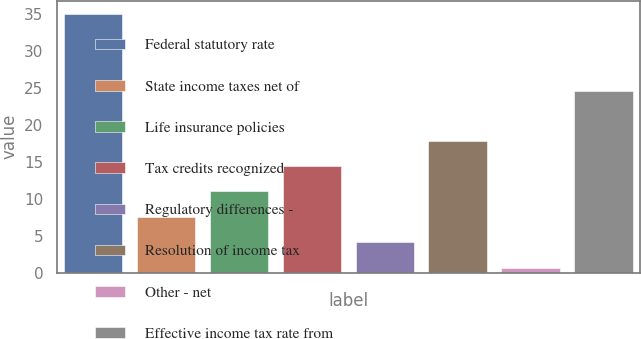Convert chart. <chart><loc_0><loc_0><loc_500><loc_500><bar_chart><fcel>Federal statutory rate<fcel>State income taxes net of<fcel>Life insurance policies<fcel>Tax credits recognized<fcel>Regulatory differences -<fcel>Resolution of income tax<fcel>Other - net<fcel>Effective income tax rate from<nl><fcel>35<fcel>7.56<fcel>10.99<fcel>14.42<fcel>4.13<fcel>17.85<fcel>0.7<fcel>24.6<nl></chart> 